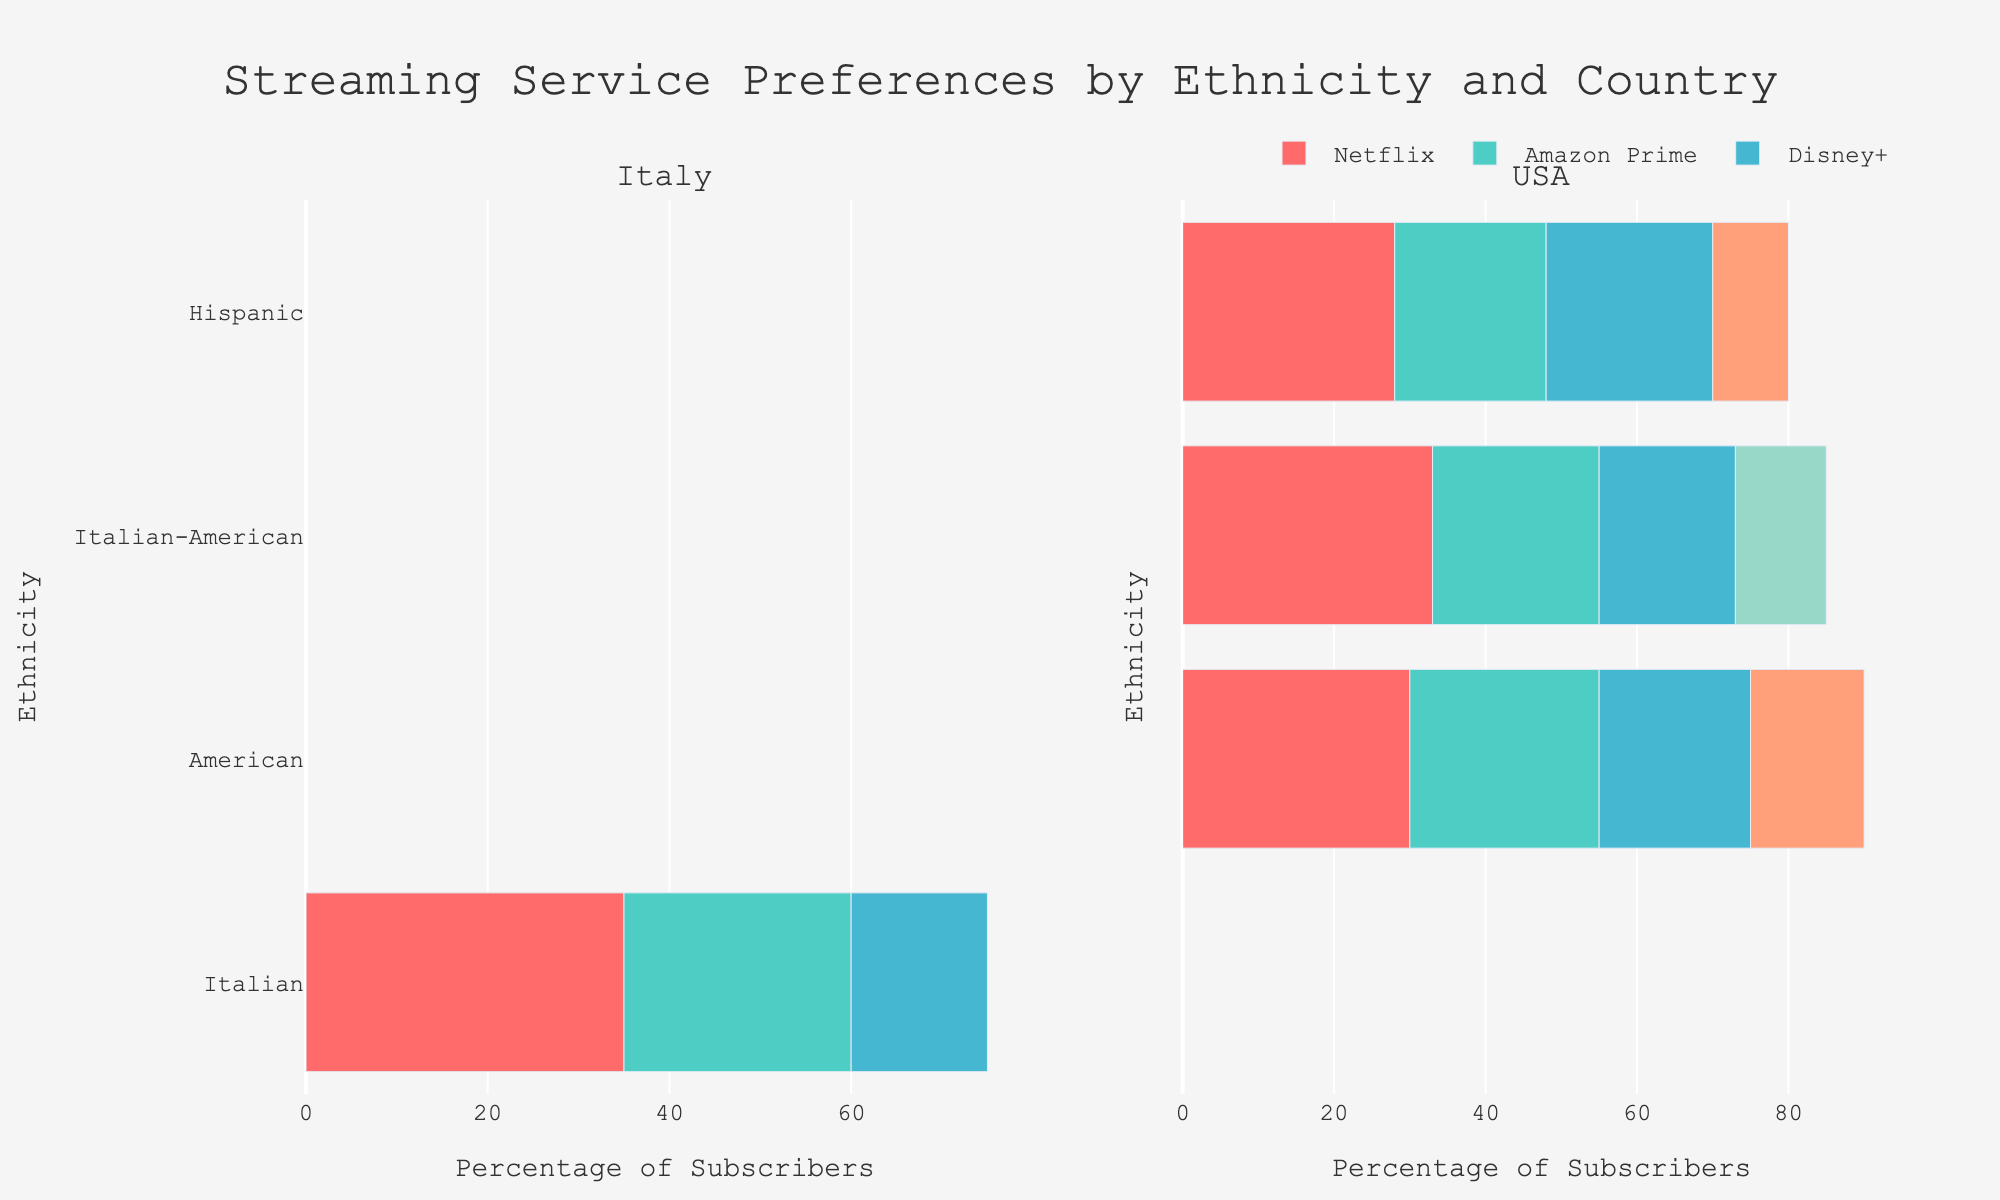Which streaming service has the highest percentage of subscribers among Italians in Italy? Look at the "Italy" subplot, and find the longest bar for Italians. Netflix has the longest bar, indicating it has the highest percentage.
Answer: Netflix What is the combined percentage of subscribers to Amazon Prime and Disney+ among Italian-Americans in the USA? In the "USA" subplot, for Italian-Americans, add the percentages of Amazon Prime (22%) and Disney+ (18%). The sum is 22 + 18 = 40.
Answer: 40% Which ethnicity has a higher subscription rate to Hulu in the USA, American or Hispanic? Compare the bars for Hulu under the "USA" subplot for both Americans and Hispanics. The Hispanic bar (10%) is shorter than the American bar (15%).
Answer: American Among Americans in the USA, by how much does the percentage of Netflix subscribers exceed Disney+ subscribers? Subtract the percentage of Disney+ subscribers (20%) from Netflix subscribers (30%) for Americans in the "USA" subplot. The difference is 30 - 20 = 10.
Answer: 10% Which country has more diversity in streaming service subscriptions for Italian-Americans, and why? Compare the number of different services subscribed to by Italian-Americans in both subplots. The "USA" has four different services (Netflix, Amazon Prime, Disney+, HBO Max) while "Italy" is not represented for Italian-Americans.
Answer: USA Out of the countries shown, which one has the highest percentage of Disney+ subscribers among all ethnicities? Compare the Disney+ bars in all subplots for each ethnicity. The highest percentage for Disney+ is 22% among Hispanics in the USA.
Answer: USA What is the least popular streaming service among Hispanics in the USA? In the "USA" subplot, look for the shortest bar among the services for Hispanics. Hulu is the shortest at 10%.
Answer: Hulu Compare the preference for Amazon Prime between Italians in Italy and Italian-Americans in the USA. Which group has a higher percentage? Look at the bars for Amazon Prime in both "Italy" and "USA" subplots. Italian-Americans show 22% vs. Italians in Italy at 25%. Italians in Italy have a higher preference.
Answer: Italians in Italy 